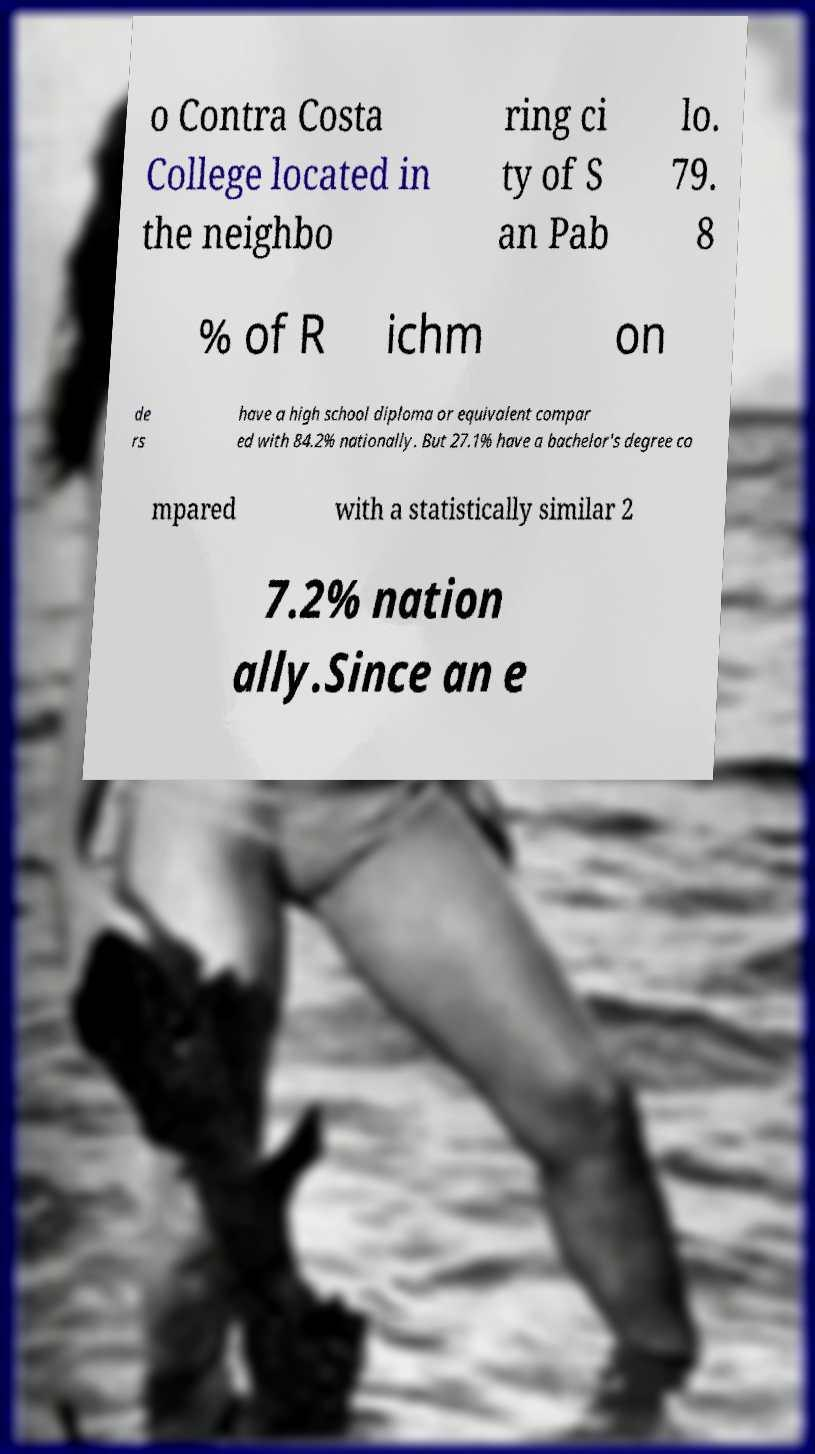Can you accurately transcribe the text from the provided image for me? o Contra Costa College located in the neighbo ring ci ty of S an Pab lo. 79. 8 % of R ichm on de rs have a high school diploma or equivalent compar ed with 84.2% nationally. But 27.1% have a bachelor's degree co mpared with a statistically similar 2 7.2% nation ally.Since an e 